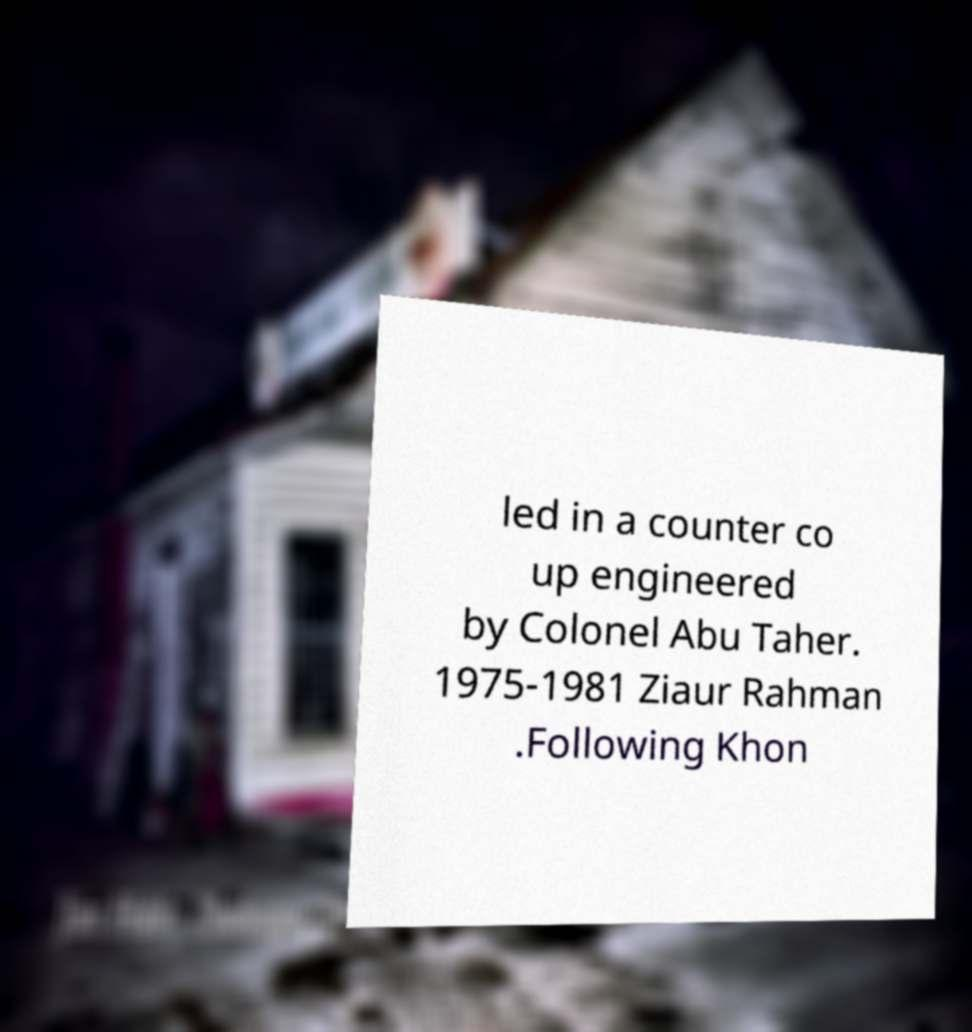Could you assist in decoding the text presented in this image and type it out clearly? led in a counter co up engineered by Colonel Abu Taher. 1975-1981 Ziaur Rahman .Following Khon 